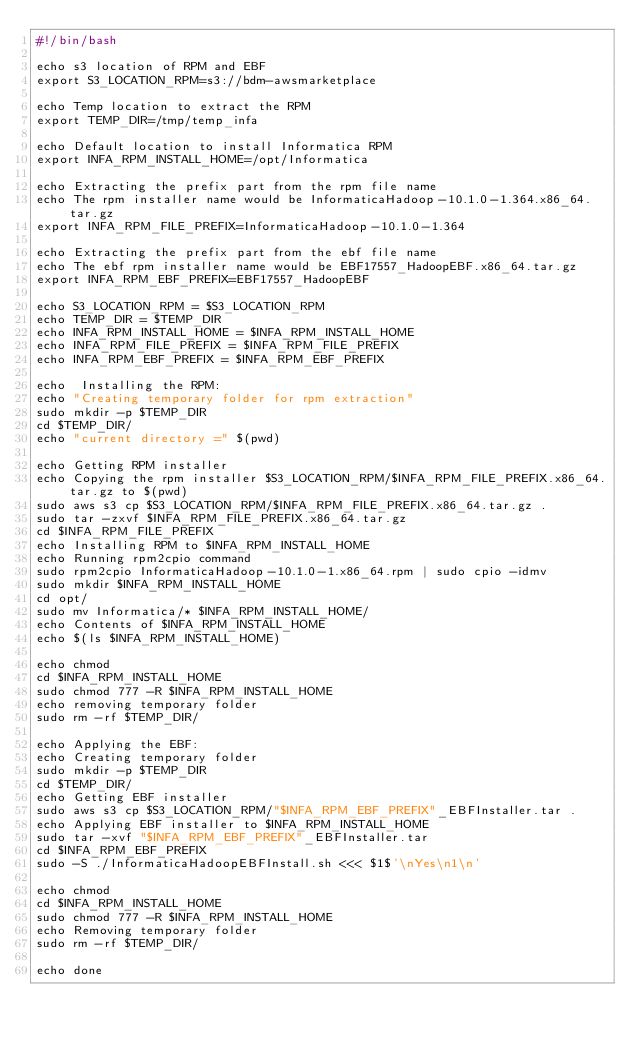Convert code to text. <code><loc_0><loc_0><loc_500><loc_500><_Bash_>#!/bin/bash

echo s3 location of RPM and EBF
export S3_LOCATION_RPM=s3://bdm-awsmarketplace

echo Temp location to extract the RPM
export TEMP_DIR=/tmp/temp_infa

echo Default location to install Informatica RPM
export INFA_RPM_INSTALL_HOME=/opt/Informatica

echo Extracting the prefix part from the rpm file name
echo The rpm installer name would be InformaticaHadoop-10.1.0-1.364.x86_64.tar.gz
export INFA_RPM_FILE_PREFIX=InformaticaHadoop-10.1.0-1.364

echo Extracting the prefix part from the ebf file name
echo The ebf rpm installer name would be EBF17557_HadoopEBF.x86_64.tar.gz
export INFA_RPM_EBF_PREFIX=EBF17557_HadoopEBF

echo S3_LOCATION_RPM = $S3_LOCATION_RPM
echo TEMP_DIR = $TEMP_DIR
echo INFA_RPM_INSTALL_HOME = $INFA_RPM_INSTALL_HOME
echo INFA_RPM_FILE_PREFIX = $INFA_RPM_FILE_PREFIX
echo INFA_RPM_EBF_PREFIX = $INFA_RPM_EBF_PREFIX

echo  Installing the RPM:
echo "Creating temporary folder for rpm extraction"
sudo mkdir -p $TEMP_DIR
cd $TEMP_DIR/
echo "current directory =" $(pwd)

echo Getting RPM installer
echo Copying the rpm installer $S3_LOCATION_RPM/$INFA_RPM_FILE_PREFIX.x86_64.tar.gz to $(pwd)
sudo aws s3 cp $S3_LOCATION_RPM/$INFA_RPM_FILE_PREFIX.x86_64.tar.gz .
sudo tar -zxvf $INFA_RPM_FILE_PREFIX.x86_64.tar.gz
cd $INFA_RPM_FILE_PREFIX
echo Installing RPM to $INFA_RPM_INSTALL_HOME
echo Running rpm2cpio command
sudo rpm2cpio InformaticaHadoop-10.1.0-1.x86_64.rpm | sudo cpio -idmv
sudo mkdir $INFA_RPM_INSTALL_HOME
cd opt/
sudo mv Informatica/* $INFA_RPM_INSTALL_HOME/
echo Contents of $INFA_RPM_INSTALL_HOME
echo $(ls $INFA_RPM_INSTALL_HOME)

echo chmod
cd $INFA_RPM_INSTALL_HOME
sudo chmod 777 -R $INFA_RPM_INSTALL_HOME
echo removing temporary folder
sudo rm -rf $TEMP_DIR/

echo Applying the EBF:
echo Creating temporary folder
sudo mkdir -p $TEMP_DIR
cd $TEMP_DIR/
echo Getting EBF installer
sudo aws s3 cp $S3_LOCATION_RPM/"$INFA_RPM_EBF_PREFIX"_EBFInstaller.tar .
echo Applying EBF installer to $INFA_RPM_INSTALL_HOME
sudo tar -xvf "$INFA_RPM_EBF_PREFIX"_EBFInstaller.tar
cd $INFA_RPM_EBF_PREFIX
sudo -S ./InformaticaHadoopEBFInstall.sh <<< $1$'\nYes\n1\n'

echo chmod
cd $INFA_RPM_INSTALL_HOME
sudo chmod 777 -R $INFA_RPM_INSTALL_HOME
echo Removing temporary folder
sudo rm -rf $TEMP_DIR/

echo done
</code> 